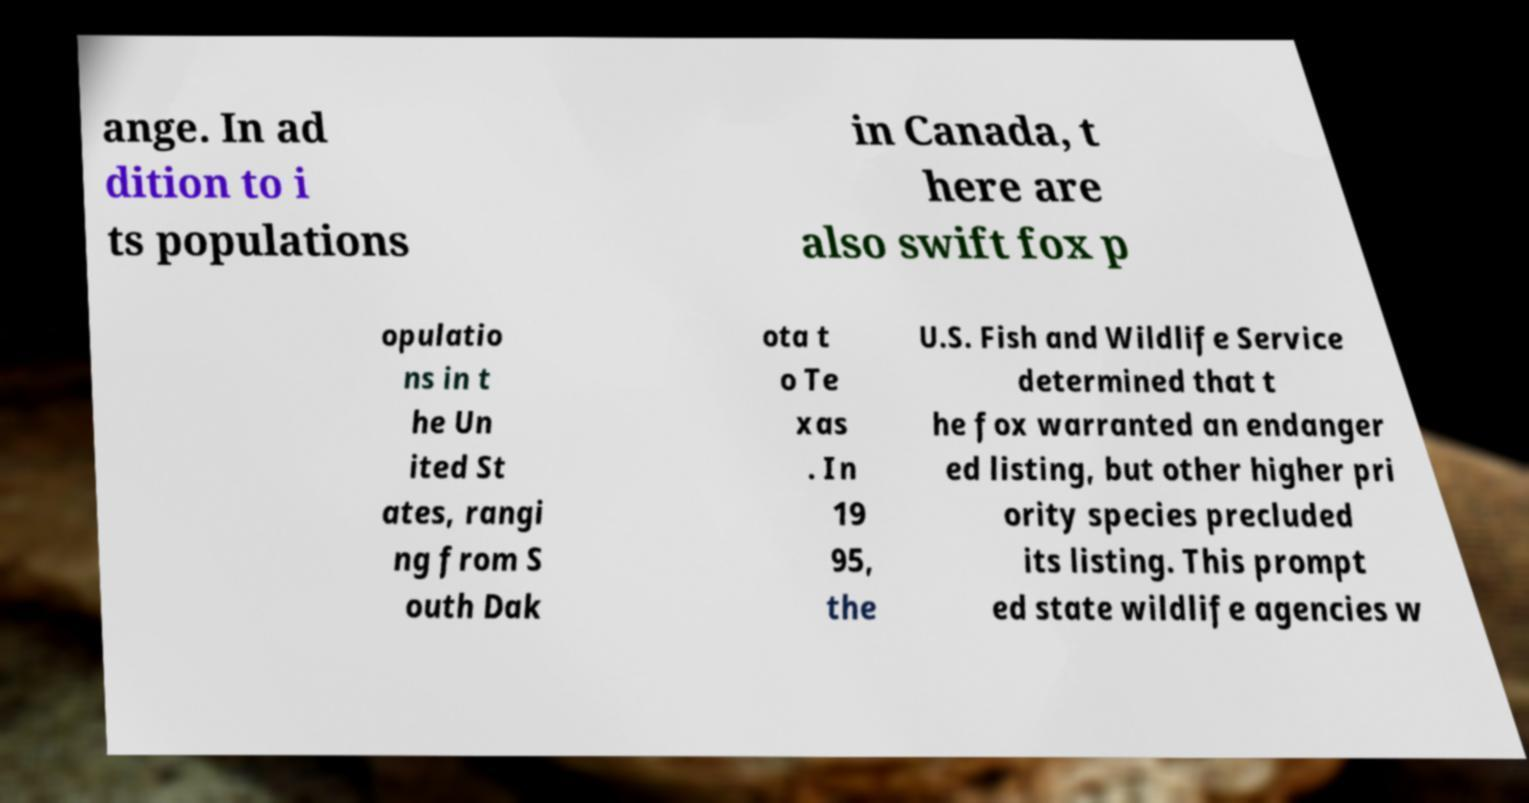There's text embedded in this image that I need extracted. Can you transcribe it verbatim? ange. In ad dition to i ts populations in Canada, t here are also swift fox p opulatio ns in t he Un ited St ates, rangi ng from S outh Dak ota t o Te xas . In 19 95, the U.S. Fish and Wildlife Service determined that t he fox warranted an endanger ed listing, but other higher pri ority species precluded its listing. This prompt ed state wildlife agencies w 